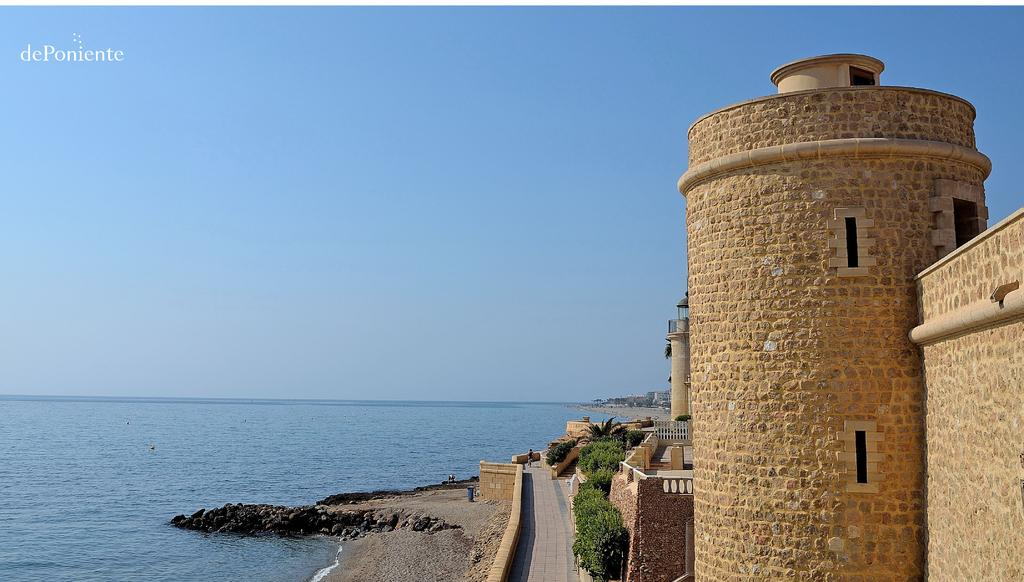What type of structures can be seen in the image? There are buildings in the image. What other natural elements are present in the image? There are trees and water visible in the image. What type of surface is present for walking or transportation? There is a sidewalk in the image. What is the color of the sky in the image? The sky is blue in the image. Can you see any birds flying over the water in the image? There are no birds visible in the image. Is there any coal present in the image? There is no coal present in the image. 